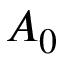<formula> <loc_0><loc_0><loc_500><loc_500>A _ { 0 }</formula> 